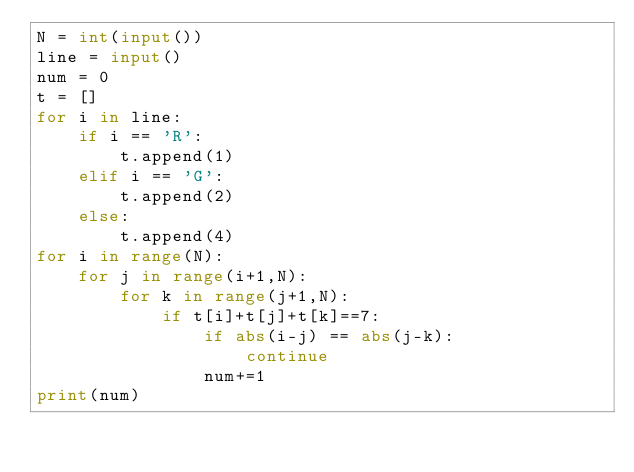<code> <loc_0><loc_0><loc_500><loc_500><_Python_>N = int(input())
line = input()
num = 0
t = []
for i in line:
    if i == 'R':
        t.append(1)
    elif i == 'G':
        t.append(2)
    else:
        t.append(4)
for i in range(N):
    for j in range(i+1,N):
        for k in range(j+1,N):
            if t[i]+t[j]+t[k]==7:
                if abs(i-j) == abs(j-k):
                    continue
                num+=1
print(num)</code> 